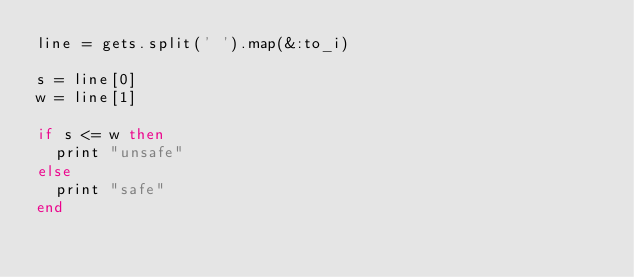<code> <loc_0><loc_0><loc_500><loc_500><_Ruby_>line = gets.split(' ').map(&:to_i)
 
s = line[0]
w = line[1]
 
if s <= w then
  print "unsafe"
else
  print "safe"
end</code> 